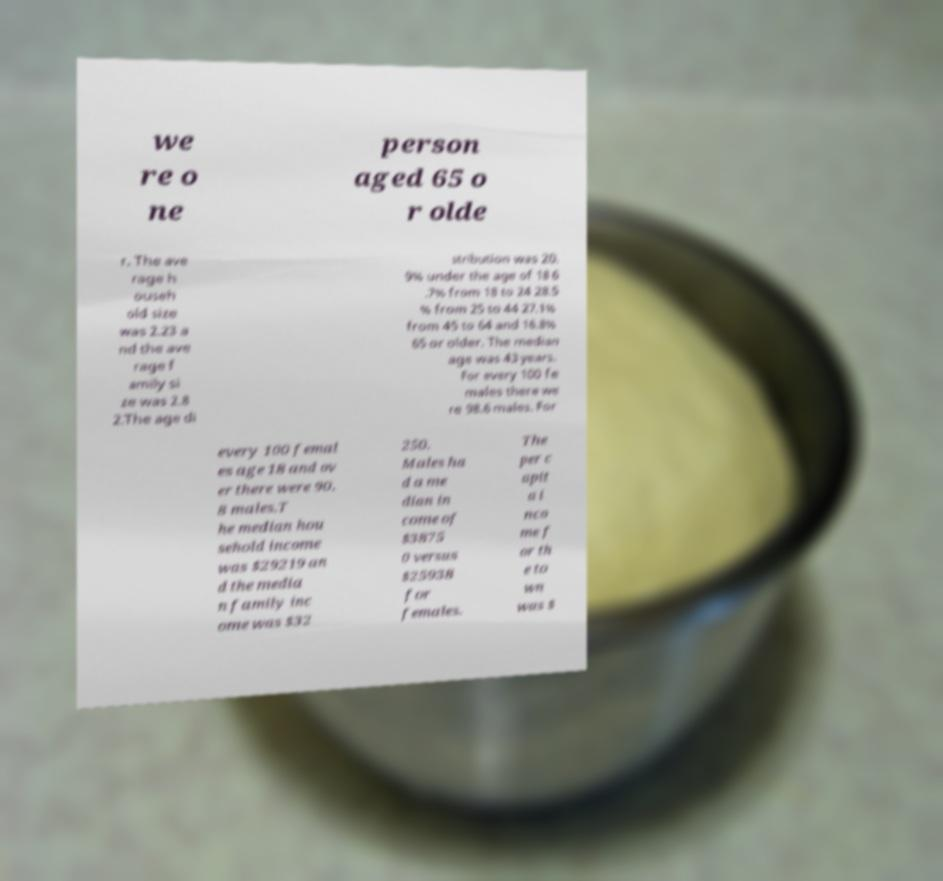For documentation purposes, I need the text within this image transcribed. Could you provide that? we re o ne person aged 65 o r olde r. The ave rage h ouseh old size was 2.23 a nd the ave rage f amily si ze was 2.8 2.The age di stribution was 20. 9% under the age of 18 6 .7% from 18 to 24 28.5 % from 25 to 44 27.1% from 45 to 64 and 16.8% 65 or older. The median age was 43 years. For every 100 fe males there we re 98.6 males. For every 100 femal es age 18 and ov er there were 90. 8 males.T he median hou sehold income was $29219 an d the media n family inc ome was $32 250. Males ha d a me dian in come of $3875 0 versus $25938 for females. The per c apit a i nco me f or th e to wn was $ 